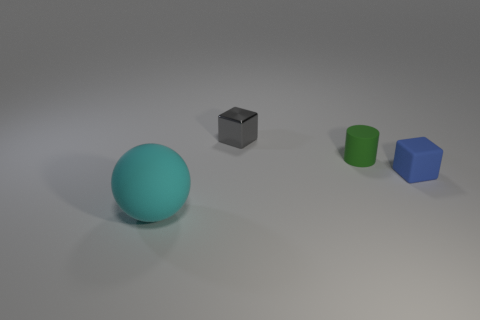Add 2 tiny red shiny cylinders. How many objects exist? 6 Subtract all cyan cubes. Subtract all red spheres. How many cubes are left? 2 Subtract all purple cubes. How many green balls are left? 0 Subtract all purple metallic things. Subtract all small green matte things. How many objects are left? 3 Add 3 small blue matte things. How many small blue matte things are left? 4 Add 4 small rubber blocks. How many small rubber blocks exist? 5 Subtract 0 brown cylinders. How many objects are left? 4 